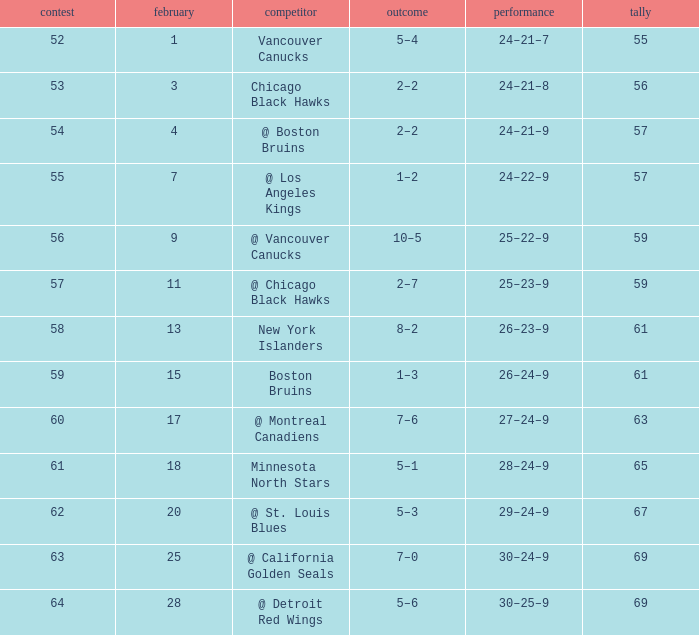Which opponent has a game larger than 61, february smaller than 28, and fewer points than 69? @ St. Louis Blues. 